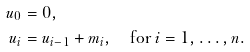Convert formula to latex. <formula><loc_0><loc_0><loc_500><loc_500>u _ { 0 } & = 0 , \\ u _ { i } & = u _ { i - 1 } + m _ { i } , \quad \text {for $i=1,\dots,n$.}</formula> 